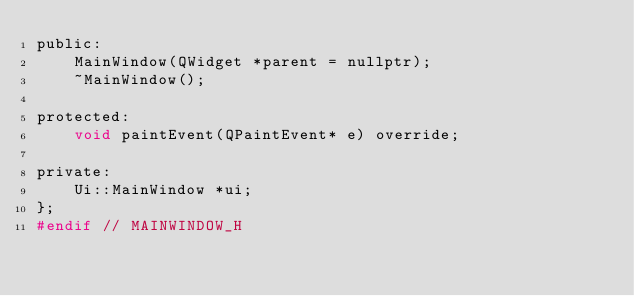Convert code to text. <code><loc_0><loc_0><loc_500><loc_500><_C_>public:
    MainWindow(QWidget *parent = nullptr);
    ~MainWindow();

protected:
    void paintEvent(QPaintEvent* e) override;

private:
    Ui::MainWindow *ui;
};
#endif // MAINWINDOW_H
</code> 